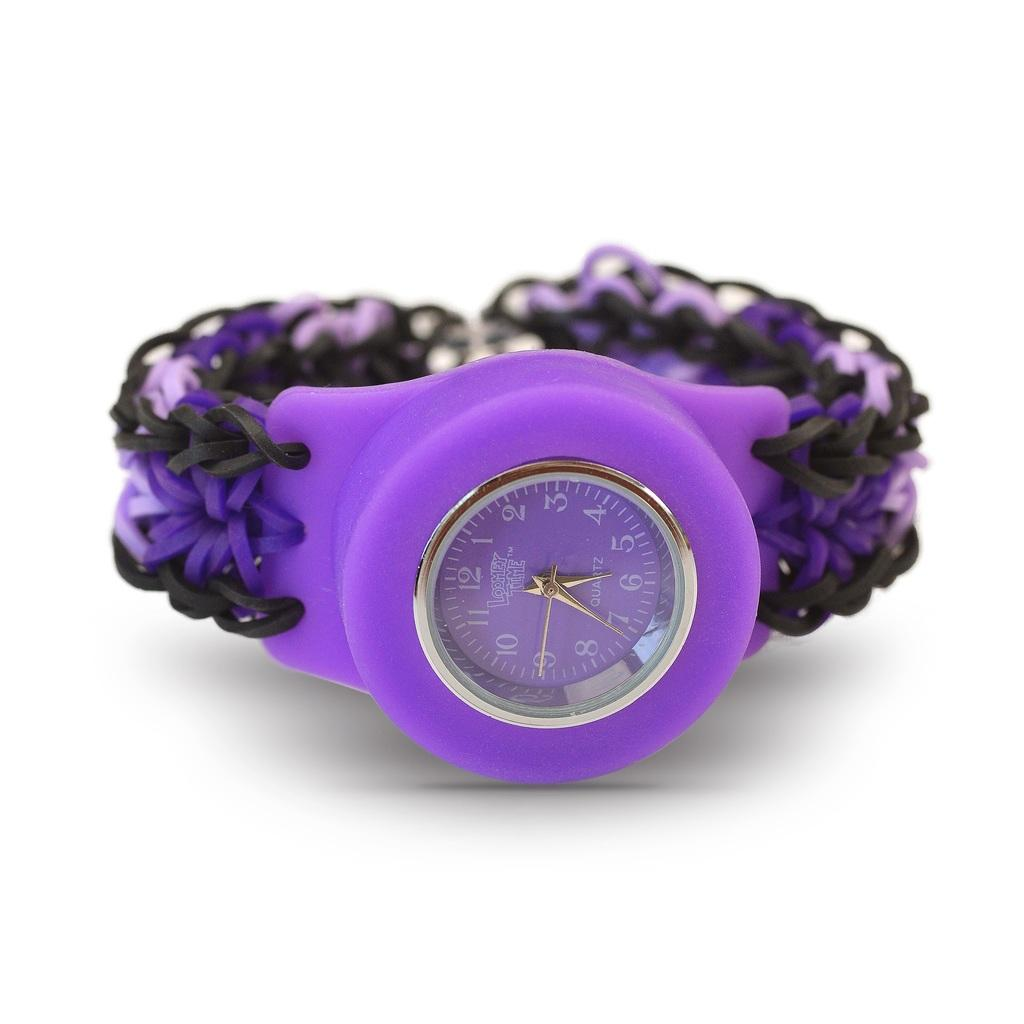<image>
Offer a succinct explanation of the picture presented. A Looney Time women's watch with plastic edging and braided leather wrist straps. 